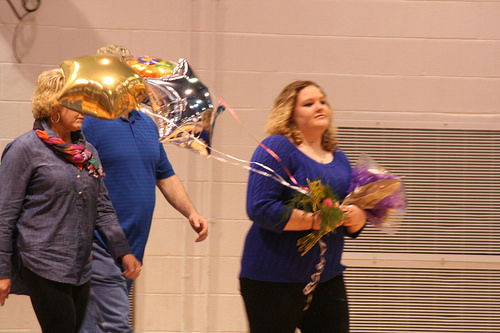<image>
Can you confirm if the shirt is in front of the flowers? No. The shirt is not in front of the flowers. The spatial positioning shows a different relationship between these objects. 